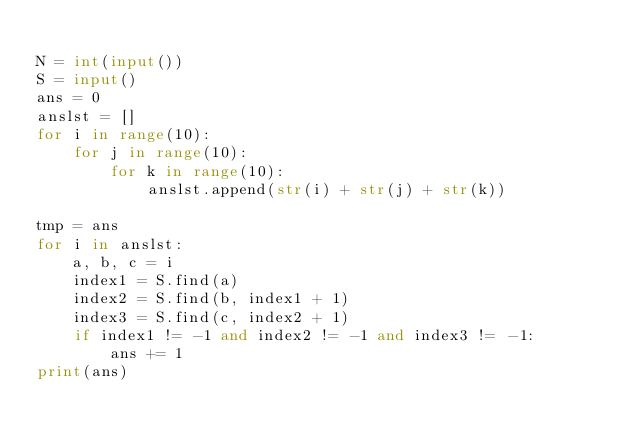Convert code to text. <code><loc_0><loc_0><loc_500><loc_500><_Python_>
N = int(input())
S = input()
ans = 0
anslst = []
for i in range(10):
    for j in range(10):
        for k in range(10):
            anslst.append(str(i) + str(j) + str(k))

tmp = ans
for i in anslst:
    a, b, c = i
    index1 = S.find(a)
    index2 = S.find(b, index1 + 1)
    index3 = S.find(c, index2 + 1)
    if index1 != -1 and index2 != -1 and index3 != -1:
        ans += 1
print(ans)</code> 